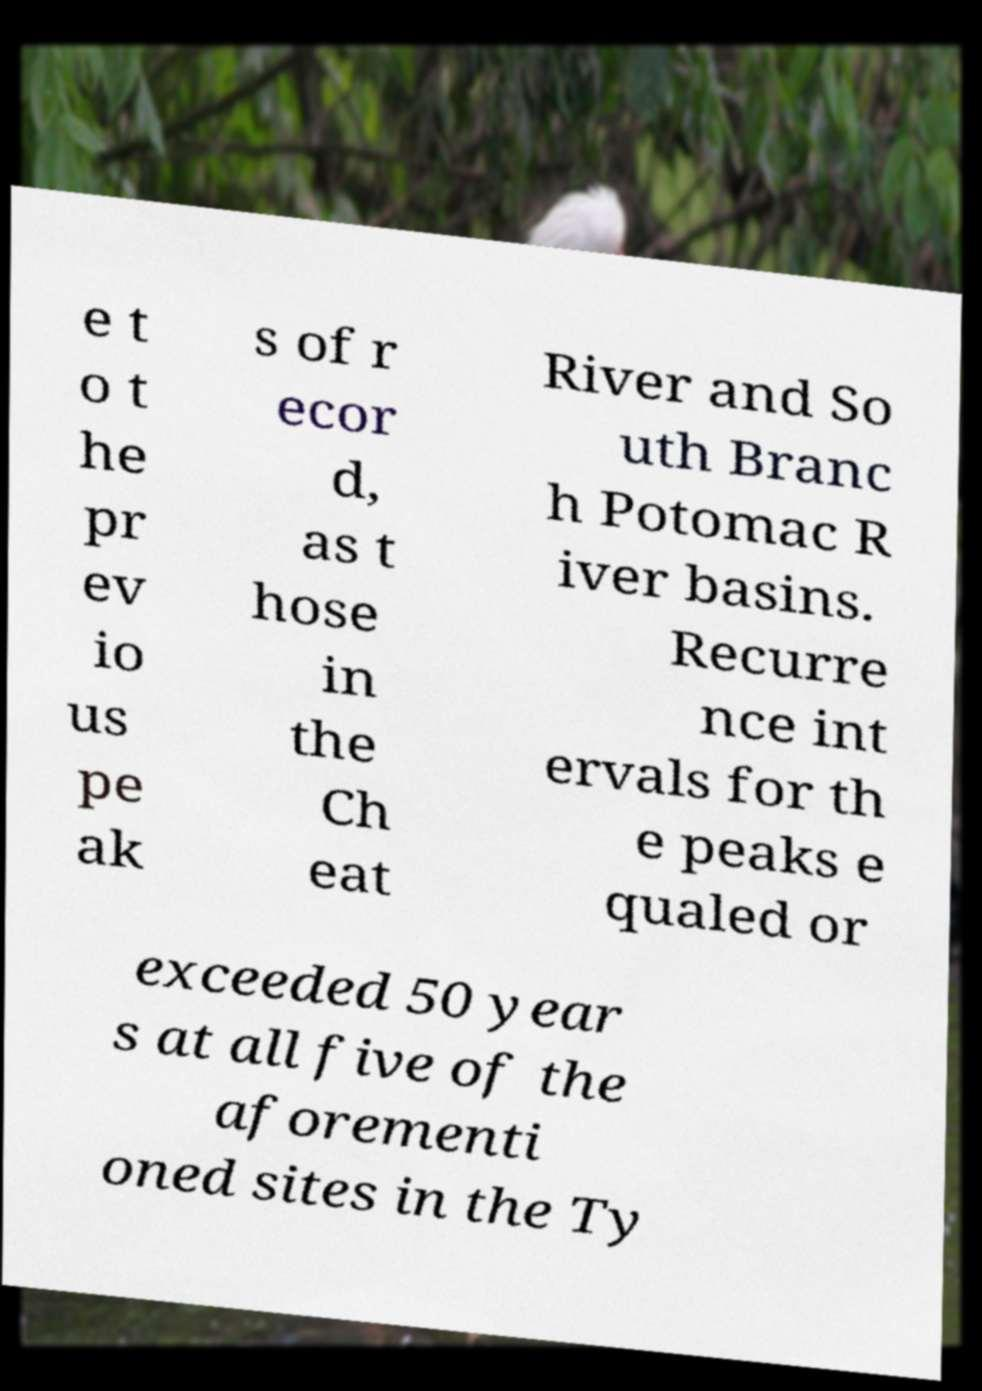What messages or text are displayed in this image? I need them in a readable, typed format. e t o t he pr ev io us pe ak s of r ecor d, as t hose in the Ch eat River and So uth Branc h Potomac R iver basins. Recurre nce int ervals for th e peaks e qualed or exceeded 50 year s at all five of the aforementi oned sites in the Ty 